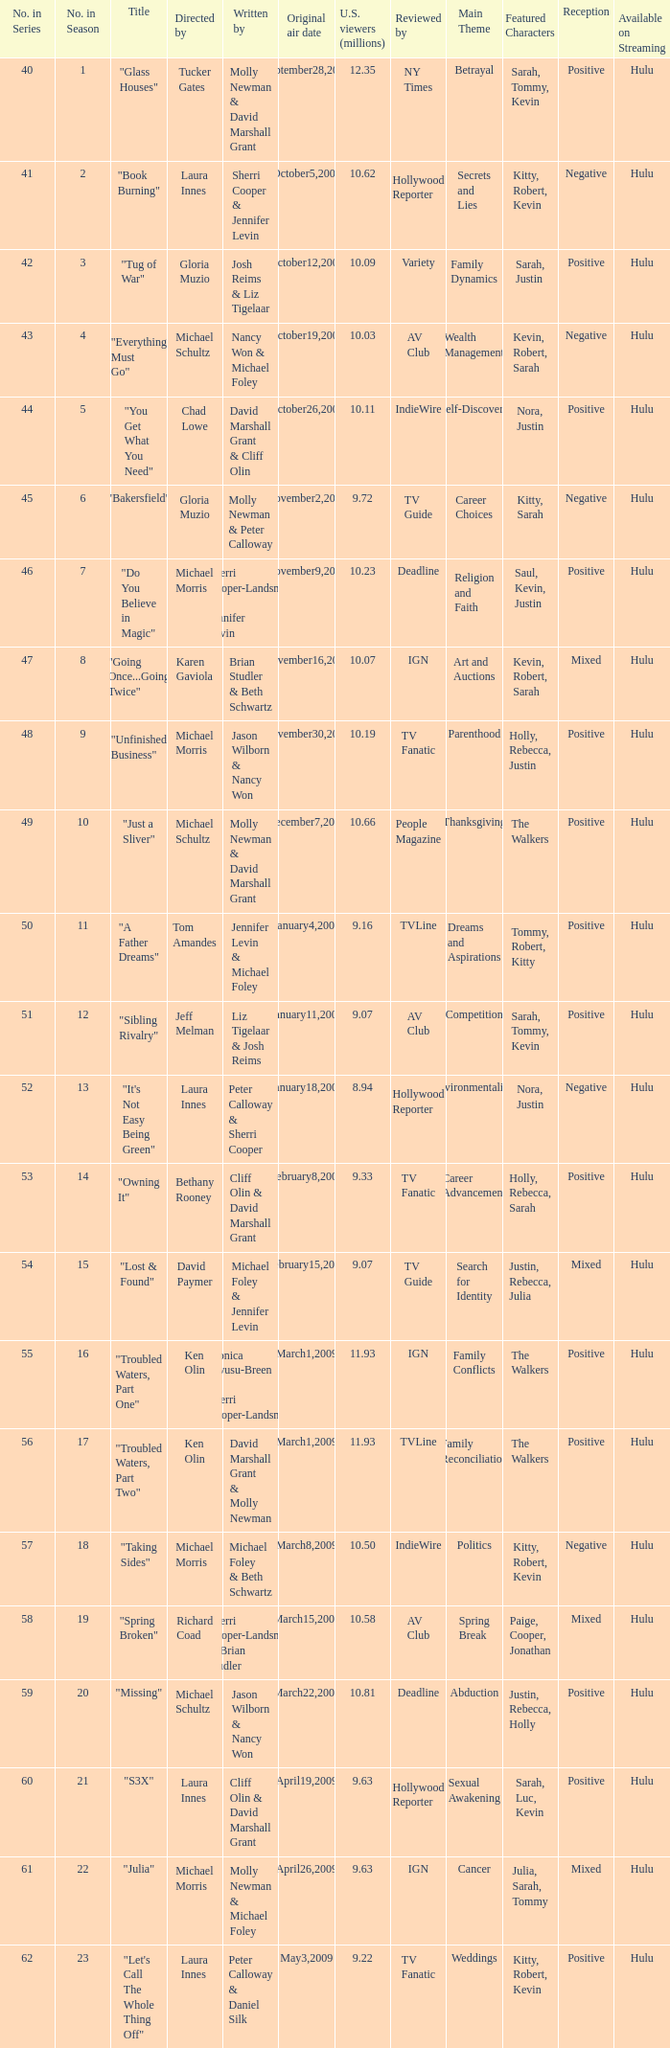When did the episode titled "Do you believe in magic" run for the first time? November9,2008. 